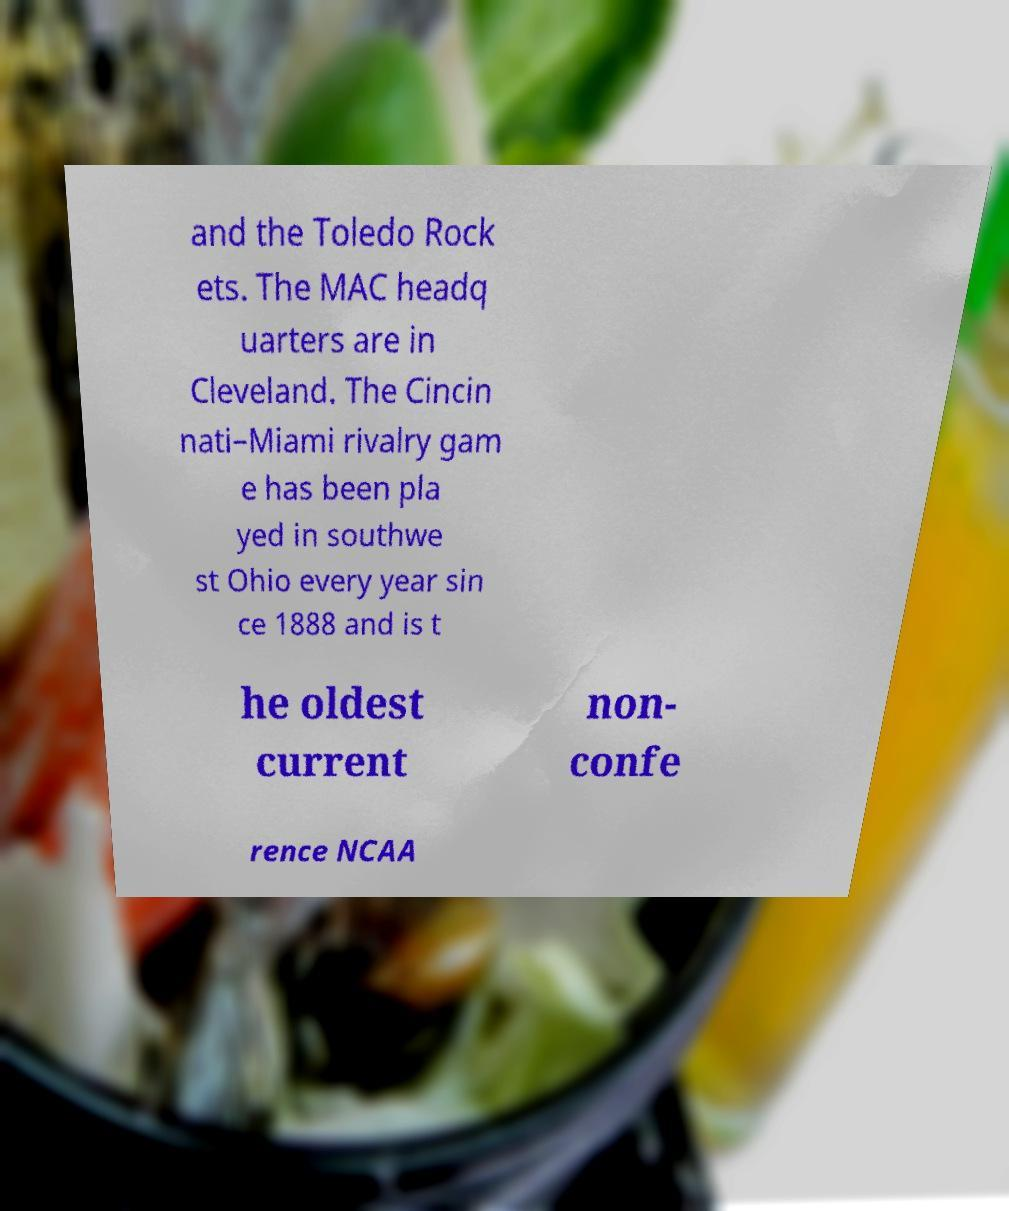Can you read and provide the text displayed in the image?This photo seems to have some interesting text. Can you extract and type it out for me? and the Toledo Rock ets. The MAC headq uarters are in Cleveland. The Cincin nati–Miami rivalry gam e has been pla yed in southwe st Ohio every year sin ce 1888 and is t he oldest current non- confe rence NCAA 